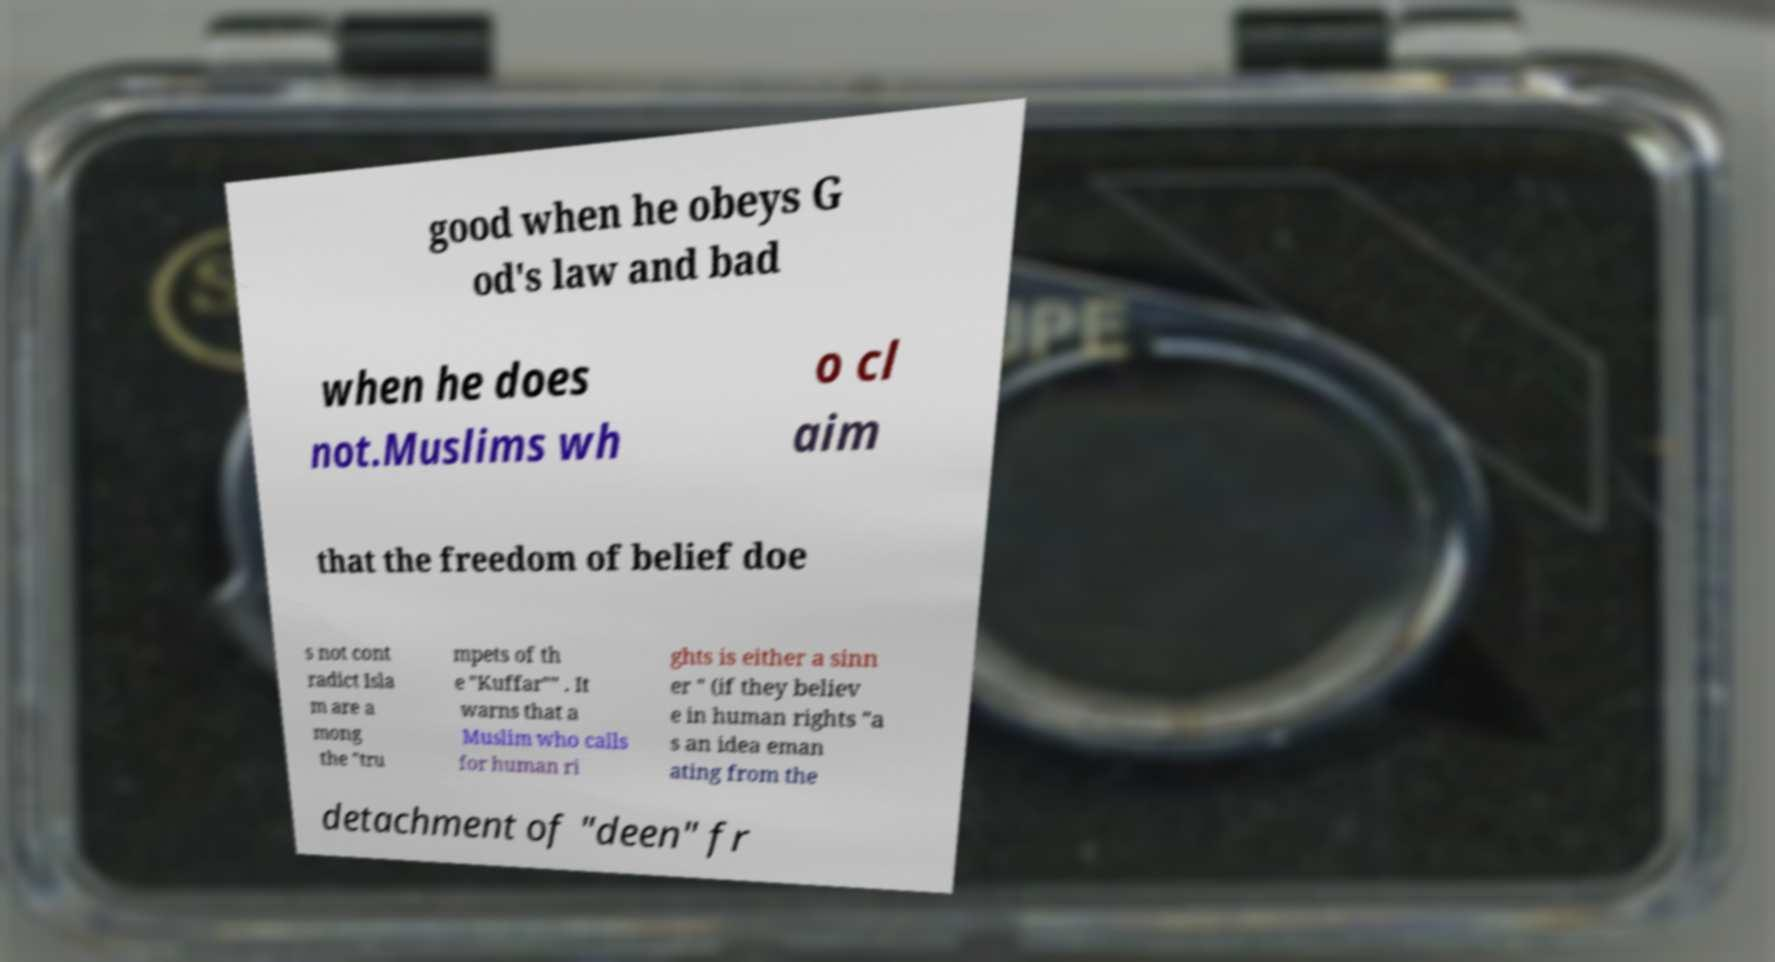Could you assist in decoding the text presented in this image and type it out clearly? good when he obeys G od's law and bad when he does not.Muslims wh o cl aim that the freedom of belief doe s not cont radict Isla m are a mong the "tru mpets of th e "Kuffar"" . It warns that a Muslim who calls for human ri ghts is either a sinn er " (if they believ e in human rights "a s an idea eman ating from the detachment of "deen" fr 